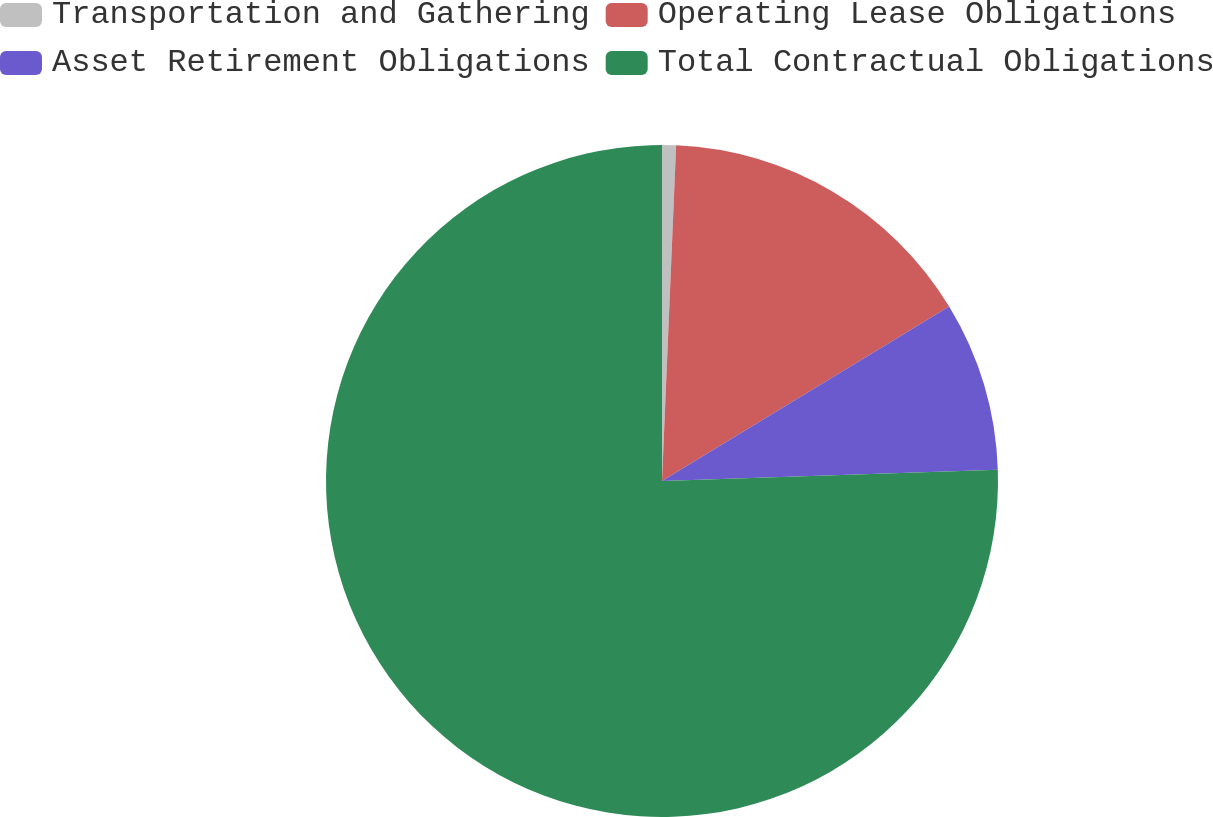<chart> <loc_0><loc_0><loc_500><loc_500><pie_chart><fcel>Transportation and Gathering<fcel>Operating Lease Obligations<fcel>Asset Retirement Obligations<fcel>Total Contractual Obligations<nl><fcel>0.67%<fcel>15.64%<fcel>8.16%<fcel>75.52%<nl></chart> 